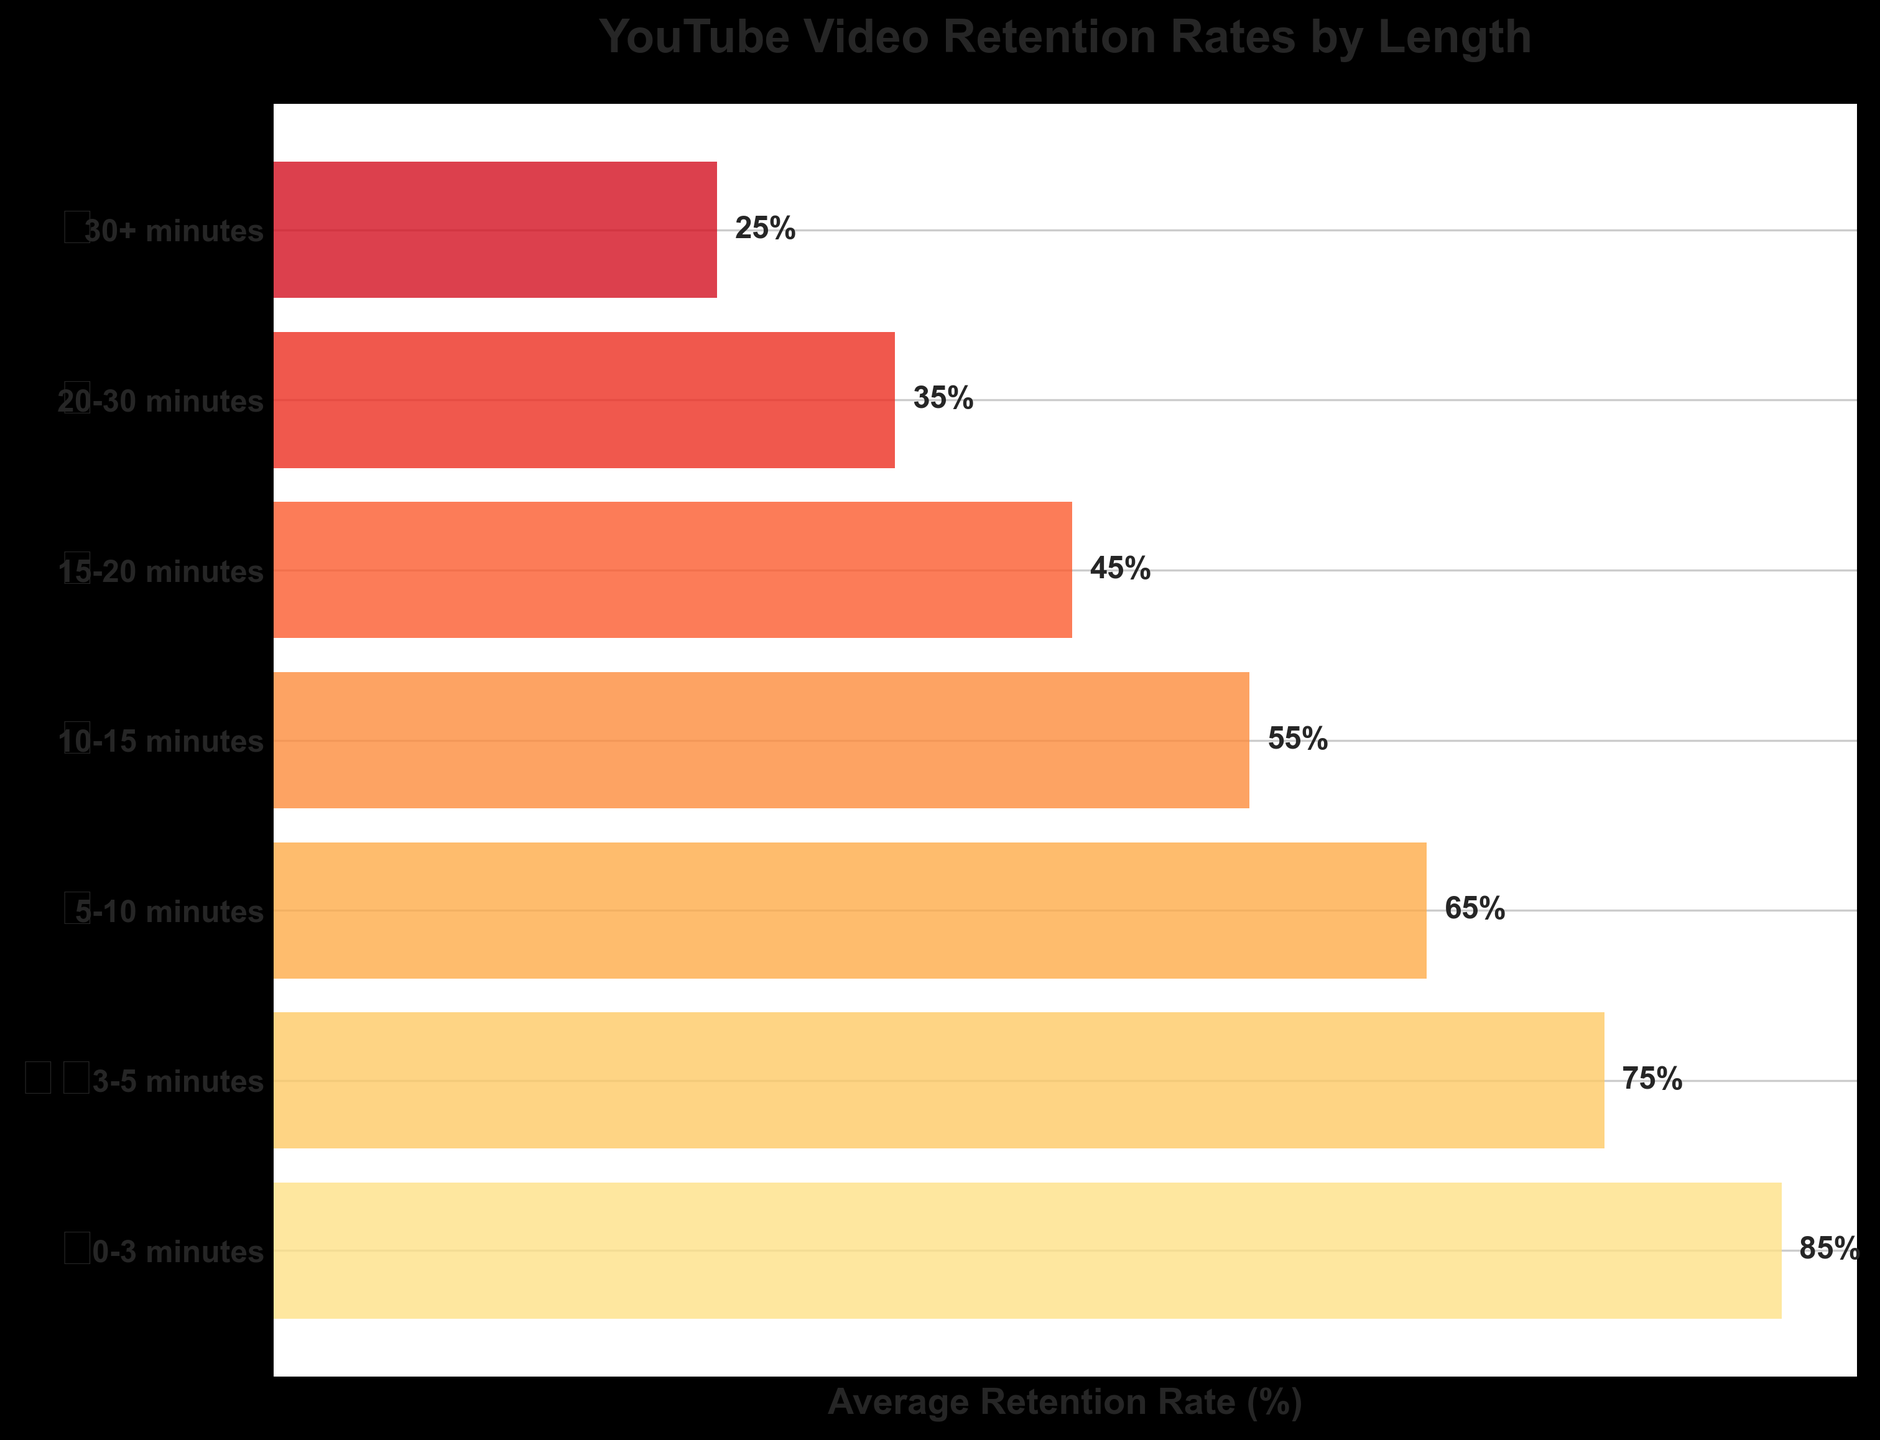What's the title of the figure? The title is written at the top of the figure and is meant to describe the main subject of the plot.
Answer: YouTube Video Retention Rates by Length How many categories of video lengths are represented in the figure? To determine the number of video length categories, count the different y-axis tick labels.
Answer: 7 What is the average retention rate for videos that are 5-10 minutes long? Locate the tick label "5-10 minutes" on the y-axis and read the corresponding bar length. The value at the end of the bar is labeled.
Answer: 65% Which video length category has the lowest average retention rate? Examine all the bars and identify the shortest one, then match it with its y-axis label.
Answer: 30+ minutes Which video length category has the highest average retention rate? Identify the longest bar on the plot and match it with its y-axis label.
Answer: 0-3 minutes What is the difference in retention rate between videos that are 15-20 minutes and 20-30 minutes? Locate the bars for both categories, read the values, and then subtract the smaller value from the larger one.
Answer: 10% Are retention rates higher for shorter videos or longer videos? Compare the retention rates of shorter video categories (e.g., 0-3 minutes) with those of longer video categories (e.g., 30+ minutes).
Answer: Shorter videos What is the retention rate for videos that are between 10-15 minutes long, and how does it compare to videos that are 0-3 minutes long? Locate the bars for both categories and compare their lengths. The retention rates are labeled at the end of each bar.
Answer: 55%, lower than 85% Is the retention rate decrease consistent as video length increases? Examine the retention rates for each subsequent video length category and check if each is consistently lower than the previous one.
Answer: Yes What is the average retention rate for videos longer than 20 minutes? Locate the bars for the categories "20-30 minutes" and "30+ minutes," then calculate the average of their labeled retention rates.
Answer: 30% 